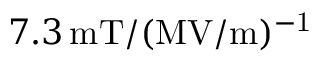Convert formula to latex. <formula><loc_0><loc_0><loc_500><loc_500>7 . 3 \, m T / ( M V / m ) ^ { - 1 }</formula> 